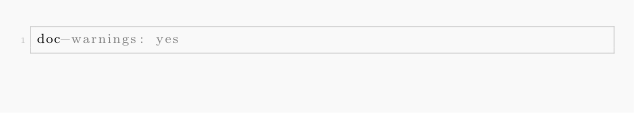Convert code to text. <code><loc_0><loc_0><loc_500><loc_500><_YAML_>doc-warnings: yes

</code> 